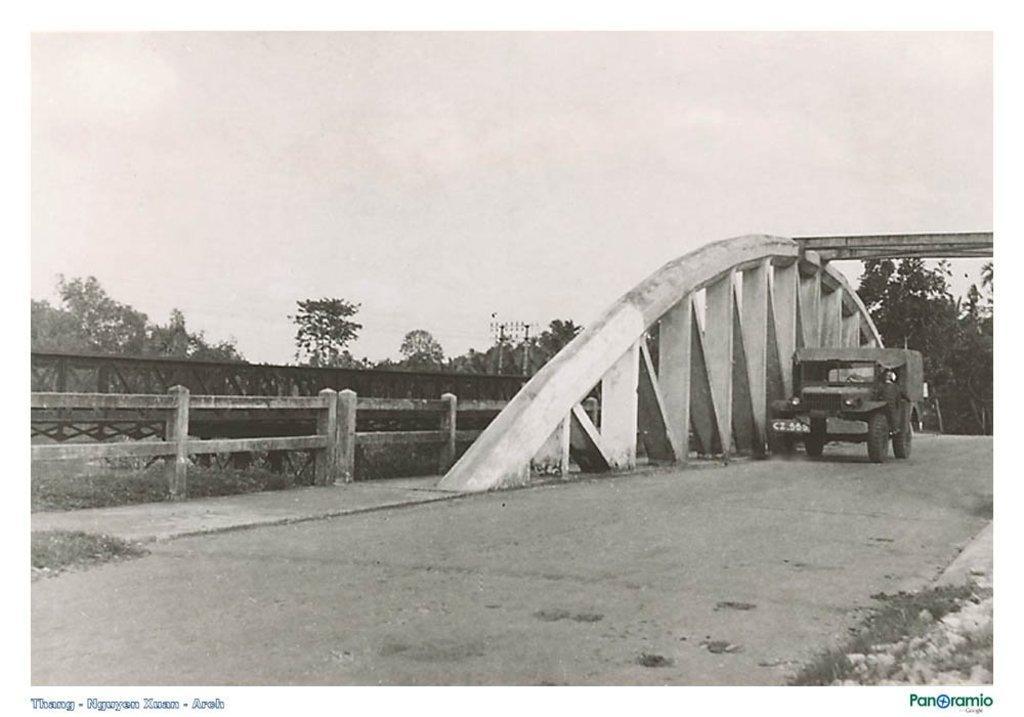Describe this image in one or two sentences. Black and white picture. Vehicle is on the road. Background there are trees and fence. 